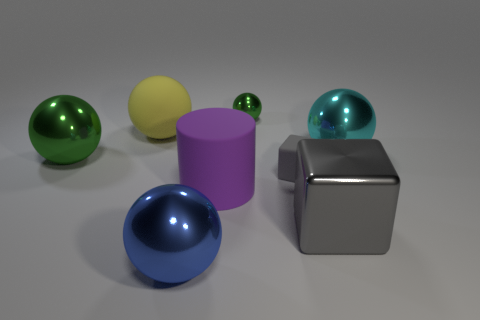What color is the metallic object that is to the left of the yellow ball? The object to the left of the yellow ball is not metallic; it appears to be a purple cylinder. The metallic object in the image is silver and is to the right of the yellow ball. 